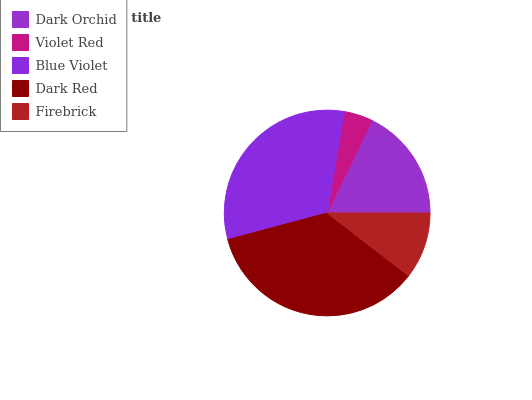Is Violet Red the minimum?
Answer yes or no. Yes. Is Dark Red the maximum?
Answer yes or no. Yes. Is Blue Violet the minimum?
Answer yes or no. No. Is Blue Violet the maximum?
Answer yes or no. No. Is Blue Violet greater than Violet Red?
Answer yes or no. Yes. Is Violet Red less than Blue Violet?
Answer yes or no. Yes. Is Violet Red greater than Blue Violet?
Answer yes or no. No. Is Blue Violet less than Violet Red?
Answer yes or no. No. Is Dark Orchid the high median?
Answer yes or no. Yes. Is Dark Orchid the low median?
Answer yes or no. Yes. Is Firebrick the high median?
Answer yes or no. No. Is Blue Violet the low median?
Answer yes or no. No. 